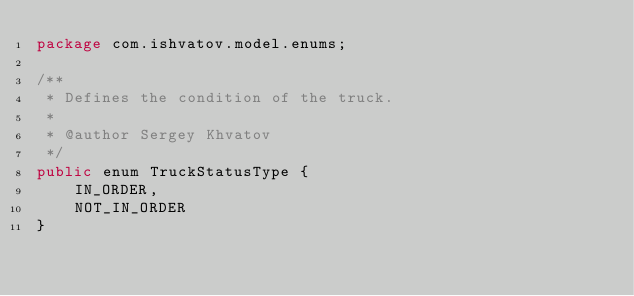Convert code to text. <code><loc_0><loc_0><loc_500><loc_500><_Java_>package com.ishvatov.model.enums;

/**
 * Defines the condition of the truck.
 *
 * @author Sergey Khvatov
 */
public enum TruckStatusType {
    IN_ORDER,
    NOT_IN_ORDER
}
</code> 